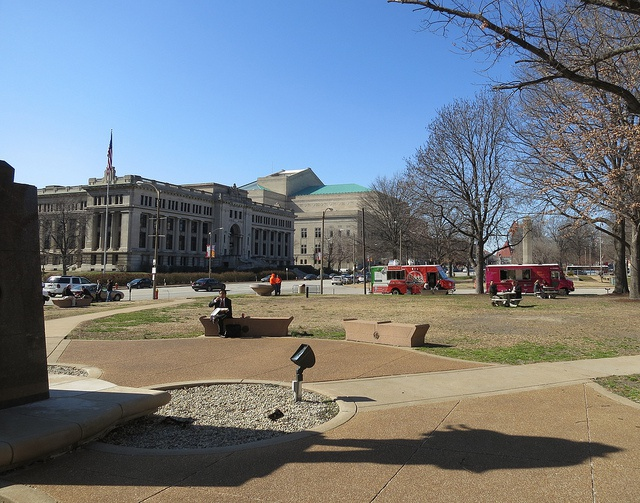Describe the objects in this image and their specific colors. I can see truck in lightblue, black, maroon, gray, and darkgray tones, truck in lightblue, maroon, black, gray, and brown tones, bench in lightblue, tan, and black tones, bench in lightblue, black, tan, and gray tones, and people in lightblue, black, darkgray, and gray tones in this image. 